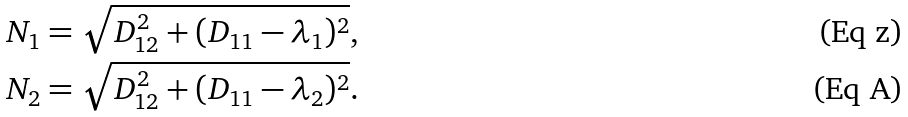Convert formula to latex. <formula><loc_0><loc_0><loc_500><loc_500>N _ { 1 } & = \sqrt { D _ { 1 2 } ^ { 2 } + ( D _ { 1 1 } - \lambda _ { 1 } ) ^ { 2 } } , \\ N _ { 2 } & = \sqrt { D _ { 1 2 } ^ { 2 } + ( D _ { 1 1 } - \lambda _ { 2 } ) ^ { 2 } } .</formula> 